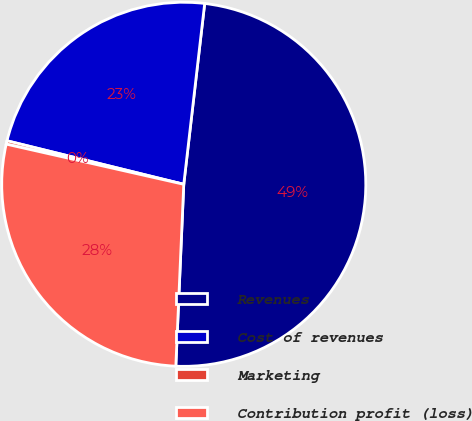Convert chart to OTSL. <chart><loc_0><loc_0><loc_500><loc_500><pie_chart><fcel>Revenues<fcel>Cost of revenues<fcel>Marketing<fcel>Contribution profit (loss)<nl><fcel>48.86%<fcel>22.99%<fcel>0.3%<fcel>27.85%<nl></chart> 